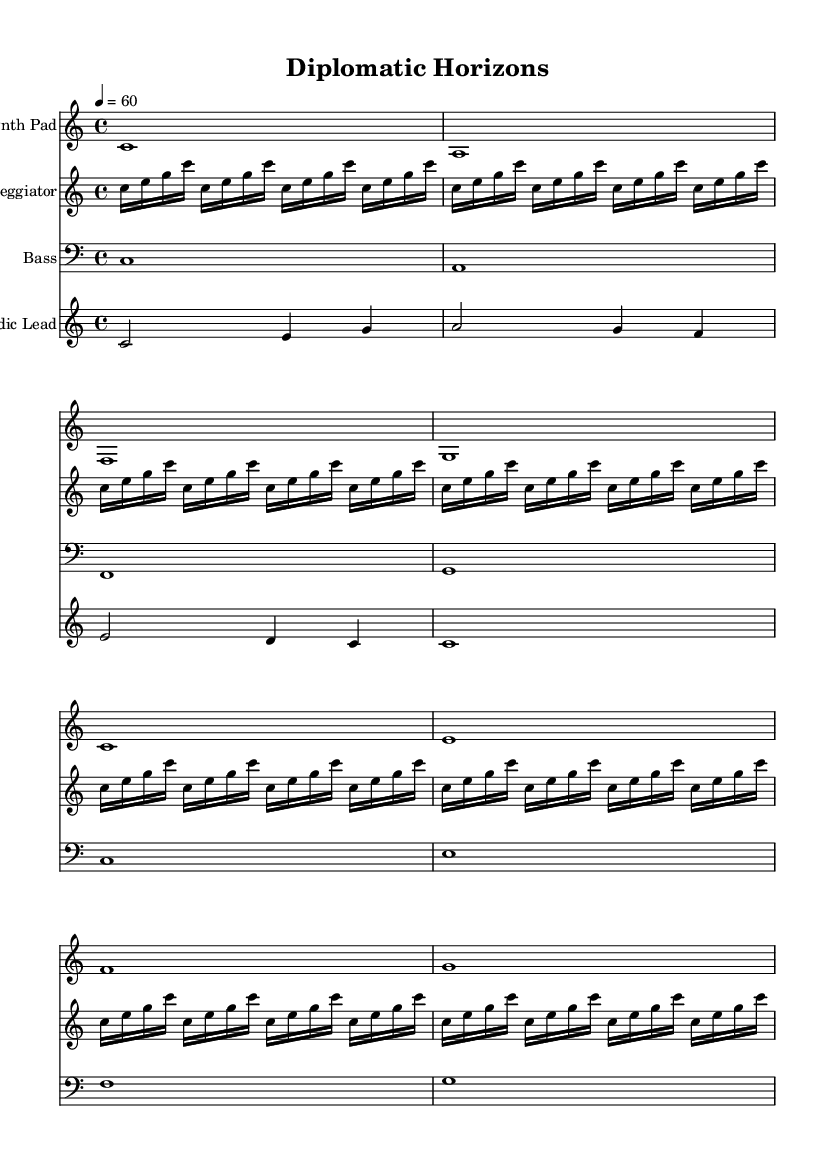What is the key signature of this music? The key signature is C major, as indicated by the absence of any sharps or flats on the staff.
Answer: C major What is the time signature of this music? The time signature is 4/4, which is shown at the beginning of the score. This means there are four beats in each measure, and the quarter note gets one beat.
Answer: 4/4 What is the tempo marking for this piece? The tempo marking indicates that the piece should be played at quarter note=60 beats per minute, meaning it is a slow tempo appropriate for ambient music.
Answer: 60 How many distinct parts are there in this composition? There are four distinct parts (or staves) including Synth Pad, Arpeggiator, Bass, and Melodic Lead, which contribute different textures to the ambient soundscape.
Answer: 4 Which instrument is primarily responsible for the harmonic background in this piece? The Synth Pad serves as the harmonic foundation, providing sustained chords that create an ambient atmosphere throughout the piece.
Answer: Synth Pad What type of rhythmic pattern does the Arpeggiator play? The Arpeggiator plays a repeating rhythmic pattern of sixteenth notes, which adds a flowing and continuous texture to the soundscape.
Answer: Sixteenth notes Which staff contains the melodic lead line? The Melodic Lead staff contains the primary melody, which is played in a higher register and adds a singing quality to the overall sound.
Answer: Melodic Lead 